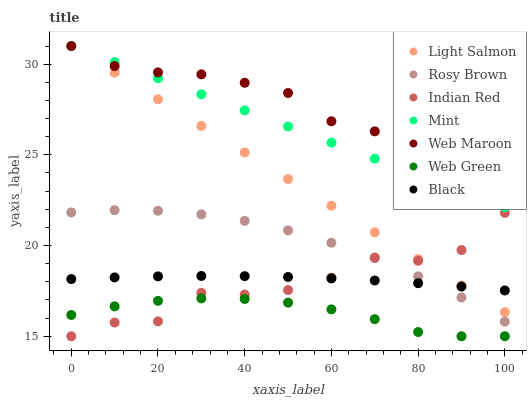Does Web Green have the minimum area under the curve?
Answer yes or no. Yes. Does Web Maroon have the maximum area under the curve?
Answer yes or no. Yes. Does Rosy Brown have the minimum area under the curve?
Answer yes or no. No. Does Rosy Brown have the maximum area under the curve?
Answer yes or no. No. Is Mint the smoothest?
Answer yes or no. Yes. Is Indian Red the roughest?
Answer yes or no. Yes. Is Rosy Brown the smoothest?
Answer yes or no. No. Is Rosy Brown the roughest?
Answer yes or no. No. Does Web Green have the lowest value?
Answer yes or no. Yes. Does Rosy Brown have the lowest value?
Answer yes or no. No. Does Mint have the highest value?
Answer yes or no. Yes. Does Rosy Brown have the highest value?
Answer yes or no. No. Is Indian Red less than Web Maroon?
Answer yes or no. Yes. Is Web Maroon greater than Indian Red?
Answer yes or no. Yes. Does Rosy Brown intersect Black?
Answer yes or no. Yes. Is Rosy Brown less than Black?
Answer yes or no. No. Is Rosy Brown greater than Black?
Answer yes or no. No. Does Indian Red intersect Web Maroon?
Answer yes or no. No. 